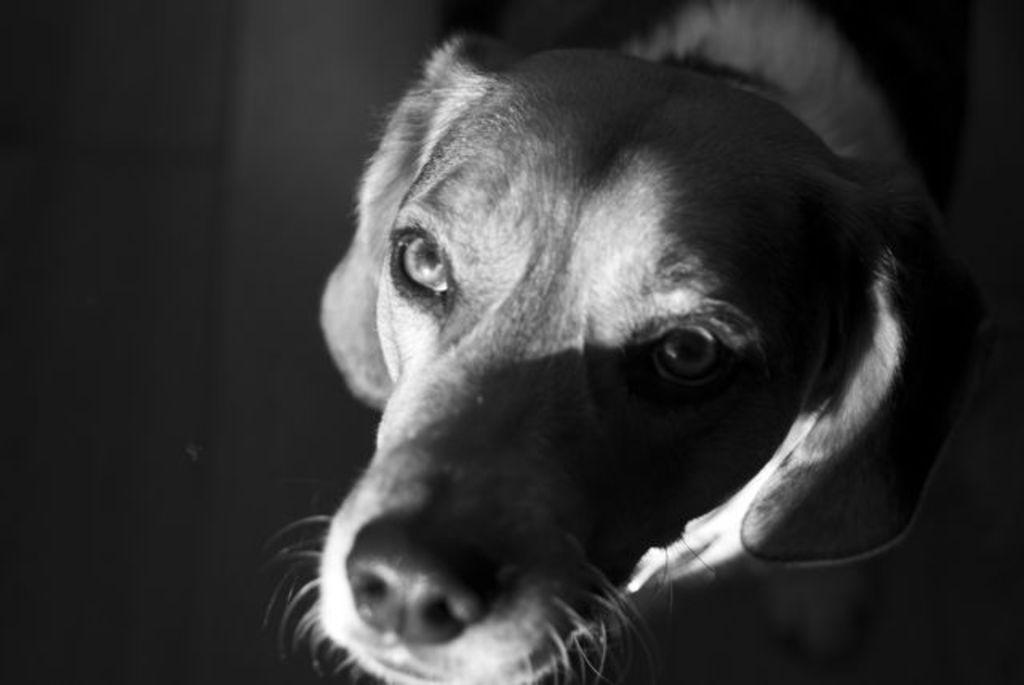What type of animal is in the image? There is a dog in the image. What color scheme is used in the image? The image is in black and white. What type of wood is the dog sitting on in the image? There is no wood present in the image; it is a black and white image of a dog. 